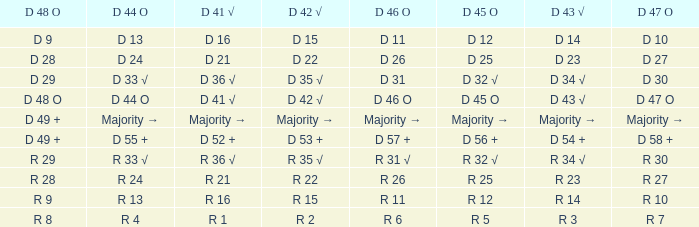Name the D 47 O with D 48 O of r 9 R 10. 